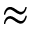Convert formula to latex. <formula><loc_0><loc_0><loc_500><loc_500>\approx</formula> 